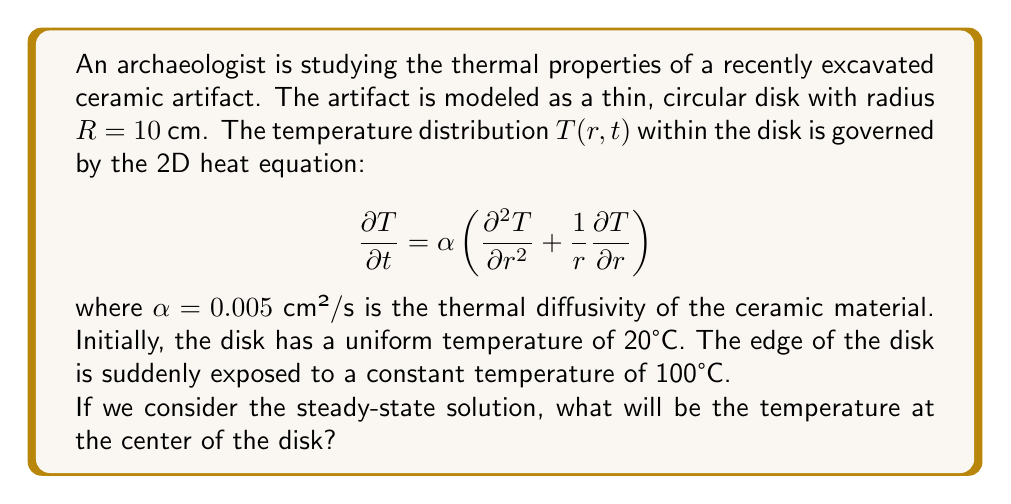What is the answer to this math problem? To solve this problem, we need to follow these steps:

1) For the steady-state solution, the temperature doesn't change with time, so $\frac{\partial T}{\partial t} = 0$. This reduces our heat equation to:

   $$0 = \frac{\partial^2 T}{\partial r^2} + \frac{1}{r}\frac{\partial T}{\partial r}$$

2) The general solution to this equation is:

   $$T(r) = A \ln(r) + B$$

   where $A$ and $B$ are constants determined by the boundary conditions.

3) We have two boundary conditions:
   - At $r = R = 10$ cm, $T = 100°C$
   - The solution must be finite at $r = 0$, which means $A$ must be 0 (because $\ln(0)$ is undefined)

4) With $A = 0$, our solution simplifies to $T(r) = B$

5) Using the boundary condition at $r = R$:

   $$100 = B$$

6) Therefore, the steady-state solution is $T(r) = 100°C$ for all $r$

7) This means that at steady state, the entire disk will be at 100°C, including the center.
Answer: The temperature at the center of the disk at steady state will be 100°C. 